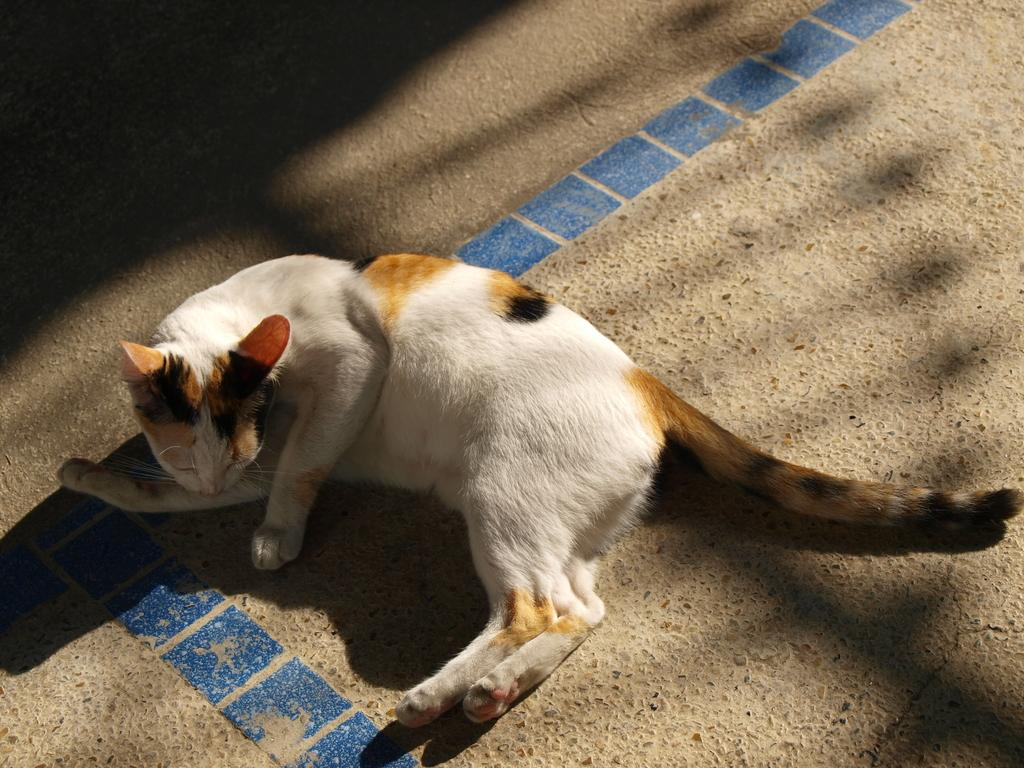What type of animal is present in the image? There is a cat in the image. What is the cat doing in the image? The cat is lying on the floor. What type of bread is the squirrel holding in the image? There is no squirrel or bread present in the image; it only features a cat lying on the floor. 